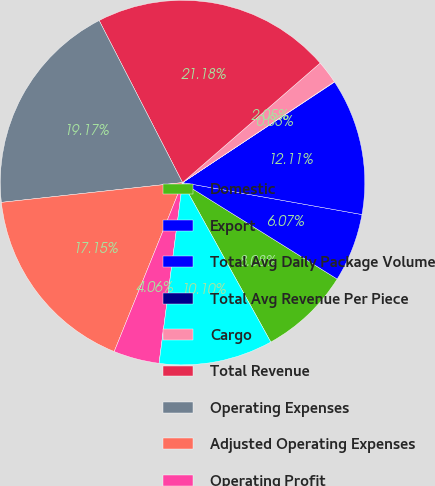<chart> <loc_0><loc_0><loc_500><loc_500><pie_chart><fcel>Domestic<fcel>Export<fcel>Total Avg Daily Package Volume<fcel>Total Avg Revenue Per Piece<fcel>Cargo<fcel>Total Revenue<fcel>Operating Expenses<fcel>Adjusted Operating Expenses<fcel>Operating Profit<fcel>Adjusted Operating Profit<nl><fcel>8.08%<fcel>6.07%<fcel>12.11%<fcel>0.03%<fcel>2.05%<fcel>21.18%<fcel>19.17%<fcel>17.15%<fcel>4.06%<fcel>10.1%<nl></chart> 